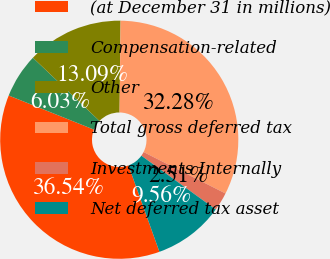Convert chart to OTSL. <chart><loc_0><loc_0><loc_500><loc_500><pie_chart><fcel>(at December 31 in millions)<fcel>Compensation-related<fcel>Other<fcel>Total gross deferred tax<fcel>Investments Internally<fcel>Net deferred tax asset<nl><fcel>36.54%<fcel>6.03%<fcel>13.09%<fcel>32.28%<fcel>2.51%<fcel>9.56%<nl></chart> 